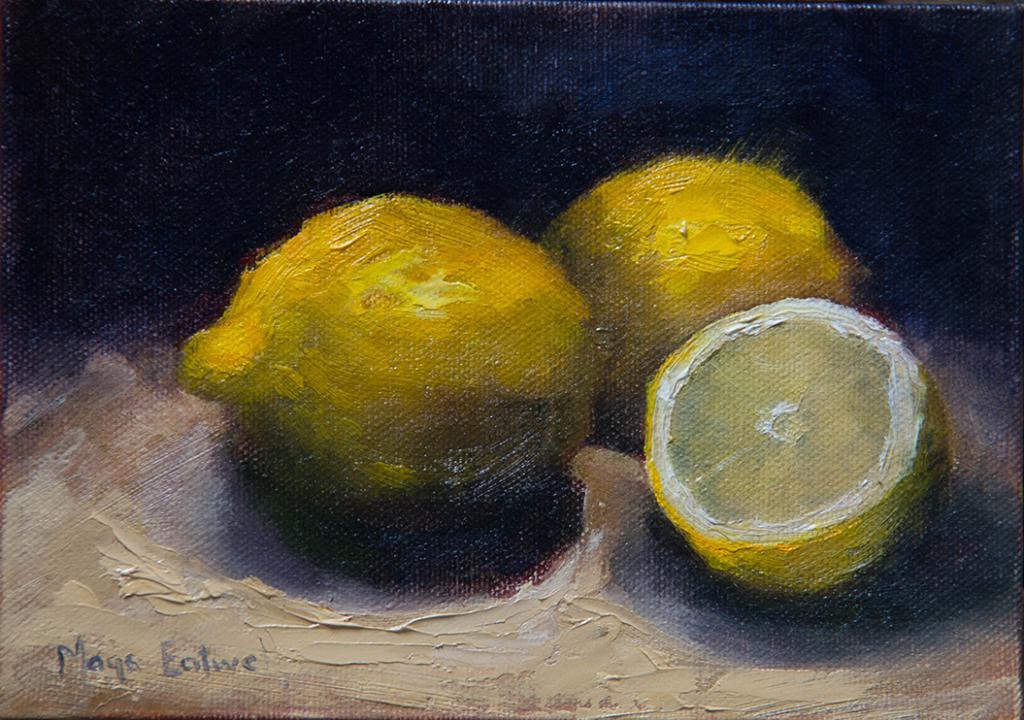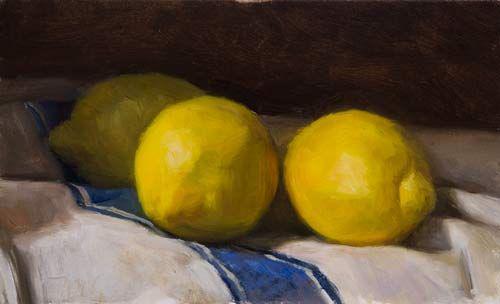The first image is the image on the left, the second image is the image on the right. Given the left and right images, does the statement "No image includes lemon leaves, and one image shows three whole lemons on white fabric with a blue stripe on it." hold true? Answer yes or no. Yes. The first image is the image on the left, the second image is the image on the right. Assess this claim about the two images: "Three lemons are laying on a white and blue cloth.". Correct or not? Answer yes or no. Yes. 